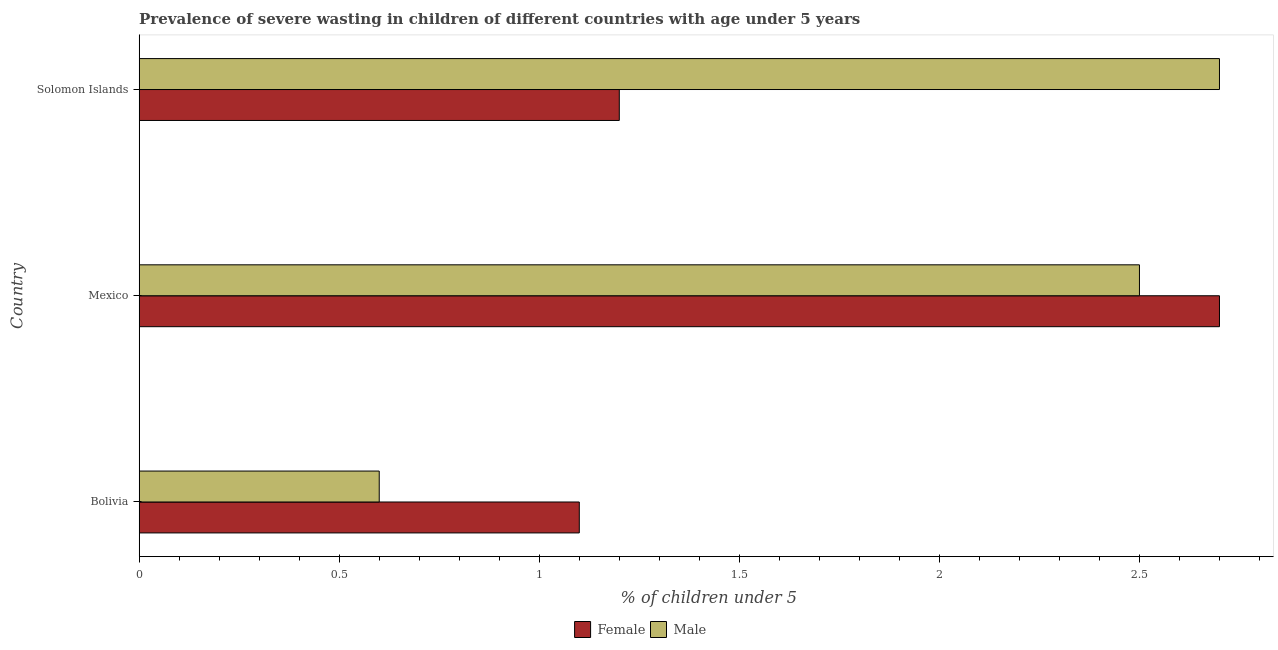How many different coloured bars are there?
Your answer should be compact. 2. Are the number of bars on each tick of the Y-axis equal?
Your response must be concise. Yes. How many bars are there on the 3rd tick from the bottom?
Ensure brevity in your answer.  2. What is the label of the 2nd group of bars from the top?
Your response must be concise. Mexico. What is the percentage of undernourished male children in Bolivia?
Provide a succinct answer. 0.6. Across all countries, what is the maximum percentage of undernourished female children?
Make the answer very short. 2.7. Across all countries, what is the minimum percentage of undernourished male children?
Your answer should be very brief. 0.6. In which country was the percentage of undernourished male children maximum?
Provide a short and direct response. Solomon Islands. What is the total percentage of undernourished female children in the graph?
Give a very brief answer. 5. What is the difference between the percentage of undernourished female children in Bolivia and that in Mexico?
Your answer should be very brief. -1.6. What is the difference between the percentage of undernourished female children in Bolivia and the percentage of undernourished male children in Solomon Islands?
Offer a very short reply. -1.6. What is the average percentage of undernourished female children per country?
Your answer should be very brief. 1.67. What is the difference between the percentage of undernourished male children and percentage of undernourished female children in Bolivia?
Offer a very short reply. -0.5. What is the ratio of the percentage of undernourished female children in Mexico to that in Solomon Islands?
Give a very brief answer. 2.25. Is the percentage of undernourished female children in Bolivia less than that in Solomon Islands?
Ensure brevity in your answer.  Yes. What is the difference between the highest and the second highest percentage of undernourished female children?
Provide a short and direct response. 1.5. What is the difference between the highest and the lowest percentage of undernourished female children?
Your answer should be compact. 1.6. Is the sum of the percentage of undernourished female children in Mexico and Solomon Islands greater than the maximum percentage of undernourished male children across all countries?
Your answer should be very brief. Yes. What does the 1st bar from the top in Bolivia represents?
Give a very brief answer. Male. What does the 2nd bar from the bottom in Mexico represents?
Provide a succinct answer. Male. How many bars are there?
Your answer should be very brief. 6. Are all the bars in the graph horizontal?
Your answer should be compact. Yes. Does the graph contain grids?
Offer a terse response. No. How are the legend labels stacked?
Offer a very short reply. Horizontal. What is the title of the graph?
Offer a terse response. Prevalence of severe wasting in children of different countries with age under 5 years. What is the label or title of the X-axis?
Offer a terse response.  % of children under 5. What is the  % of children under 5 in Female in Bolivia?
Provide a succinct answer. 1.1. What is the  % of children under 5 of Male in Bolivia?
Your response must be concise. 0.6. What is the  % of children under 5 of Female in Mexico?
Provide a short and direct response. 2.7. What is the  % of children under 5 of Male in Mexico?
Offer a terse response. 2.5. What is the  % of children under 5 in Female in Solomon Islands?
Offer a terse response. 1.2. What is the  % of children under 5 of Male in Solomon Islands?
Make the answer very short. 2.7. Across all countries, what is the maximum  % of children under 5 of Female?
Your answer should be compact. 2.7. Across all countries, what is the maximum  % of children under 5 in Male?
Your answer should be very brief. 2.7. Across all countries, what is the minimum  % of children under 5 in Female?
Offer a very short reply. 1.1. Across all countries, what is the minimum  % of children under 5 in Male?
Give a very brief answer. 0.6. What is the total  % of children under 5 of Female in the graph?
Ensure brevity in your answer.  5. What is the total  % of children under 5 in Male in the graph?
Give a very brief answer. 5.8. What is the difference between the  % of children under 5 in Female in Bolivia and that in Mexico?
Give a very brief answer. -1.6. What is the difference between the  % of children under 5 in Female in Bolivia and that in Solomon Islands?
Provide a short and direct response. -0.1. What is the difference between the  % of children under 5 in Male in Bolivia and that in Solomon Islands?
Your answer should be compact. -2.1. What is the difference between the  % of children under 5 in Female in Bolivia and the  % of children under 5 in Male in Solomon Islands?
Keep it short and to the point. -1.6. What is the average  % of children under 5 of Female per country?
Offer a very short reply. 1.67. What is the average  % of children under 5 in Male per country?
Your response must be concise. 1.93. What is the difference between the  % of children under 5 in Female and  % of children under 5 in Male in Bolivia?
Offer a terse response. 0.5. What is the difference between the  % of children under 5 of Female and  % of children under 5 of Male in Mexico?
Keep it short and to the point. 0.2. What is the difference between the  % of children under 5 in Female and  % of children under 5 in Male in Solomon Islands?
Ensure brevity in your answer.  -1.5. What is the ratio of the  % of children under 5 in Female in Bolivia to that in Mexico?
Keep it short and to the point. 0.41. What is the ratio of the  % of children under 5 in Male in Bolivia to that in Mexico?
Provide a short and direct response. 0.24. What is the ratio of the  % of children under 5 in Female in Bolivia to that in Solomon Islands?
Provide a succinct answer. 0.92. What is the ratio of the  % of children under 5 in Male in Bolivia to that in Solomon Islands?
Give a very brief answer. 0.22. What is the ratio of the  % of children under 5 in Female in Mexico to that in Solomon Islands?
Ensure brevity in your answer.  2.25. What is the ratio of the  % of children under 5 of Male in Mexico to that in Solomon Islands?
Your response must be concise. 0.93. What is the difference between the highest and the second highest  % of children under 5 of Female?
Provide a succinct answer. 1.5. What is the difference between the highest and the second highest  % of children under 5 of Male?
Provide a succinct answer. 0.2. What is the difference between the highest and the lowest  % of children under 5 in Male?
Provide a short and direct response. 2.1. 